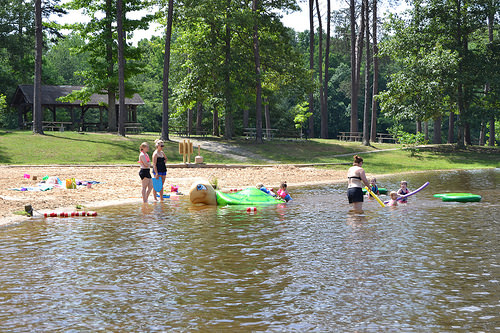<image>
Can you confirm if the water is on the woman? Yes. Looking at the image, I can see the water is positioned on top of the woman, with the woman providing support. Is the children on the turtle? Yes. Looking at the image, I can see the children is positioned on top of the turtle, with the turtle providing support. Is there a water under the hut? No. The water is not positioned under the hut. The vertical relationship between these objects is different. Where is the woman in relation to the water? Is it in the water? Yes. The woman is contained within or inside the water, showing a containment relationship. Is the woman in the water? Yes. The woman is contained within or inside the water, showing a containment relationship. 